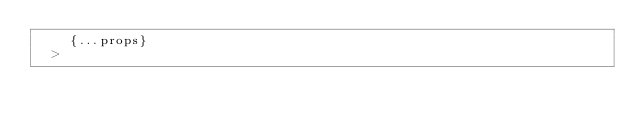Convert code to text. <code><loc_0><loc_0><loc_500><loc_500><_JavaScript_>    {...props}
  ></code> 